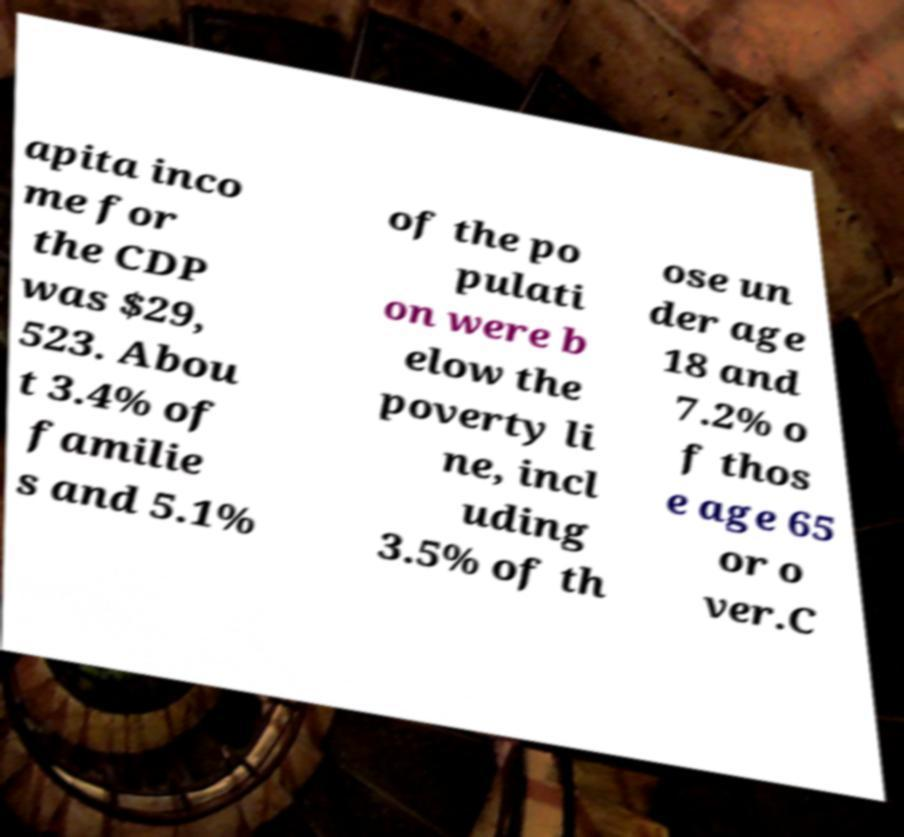Please identify and transcribe the text found in this image. apita inco me for the CDP was $29, 523. Abou t 3.4% of familie s and 5.1% of the po pulati on were b elow the poverty li ne, incl uding 3.5% of th ose un der age 18 and 7.2% o f thos e age 65 or o ver.C 